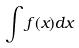Convert formula to latex. <formula><loc_0><loc_0><loc_500><loc_500>\int f ( x ) d x</formula> 